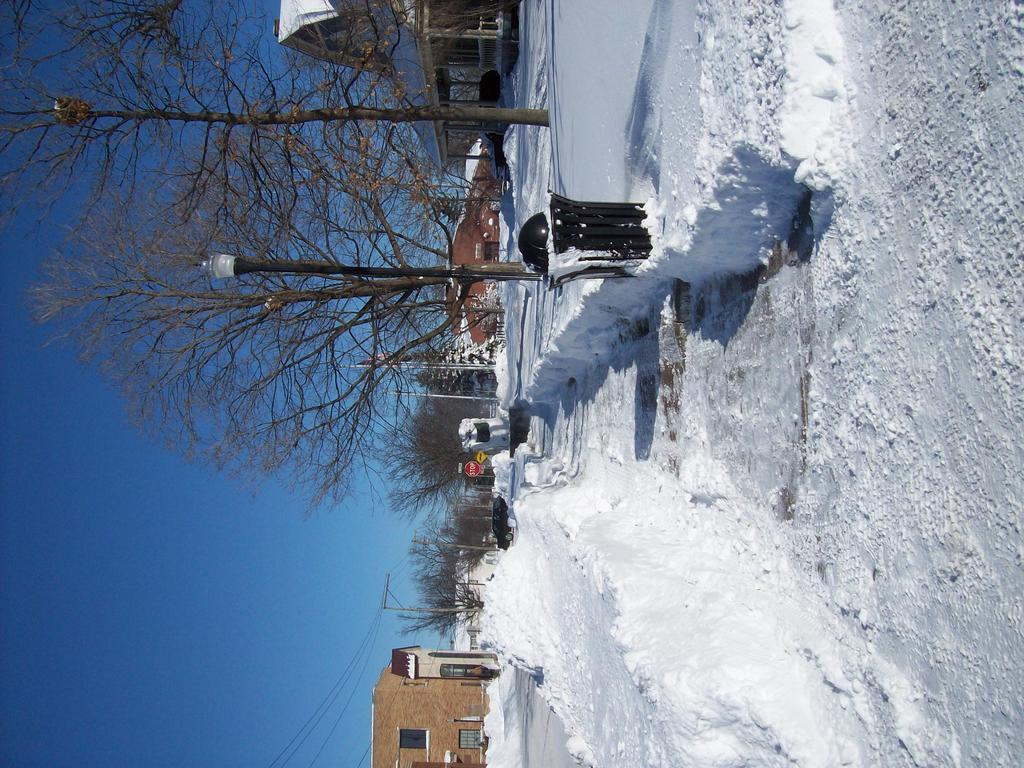What type of weather condition is depicted in the image? There is snow in the image, indicating a winter scene. What is one object that provides light in the image? There is a street lamp in the image. What type of vegetation can be seen in the image? There are trees in the image. What type of structures are visible in the image? There are houses in the image. What part of the sky is visible in the image? The sky is visible on the left side of the image. What type of utility pole can be seen in the background of the image? There is a current pole in the background of the image. How many babies are playing in the snow in the image? There are no babies present in the image; it depicts a snowy scene with a street lamp, trees, houses, and a current pole. 